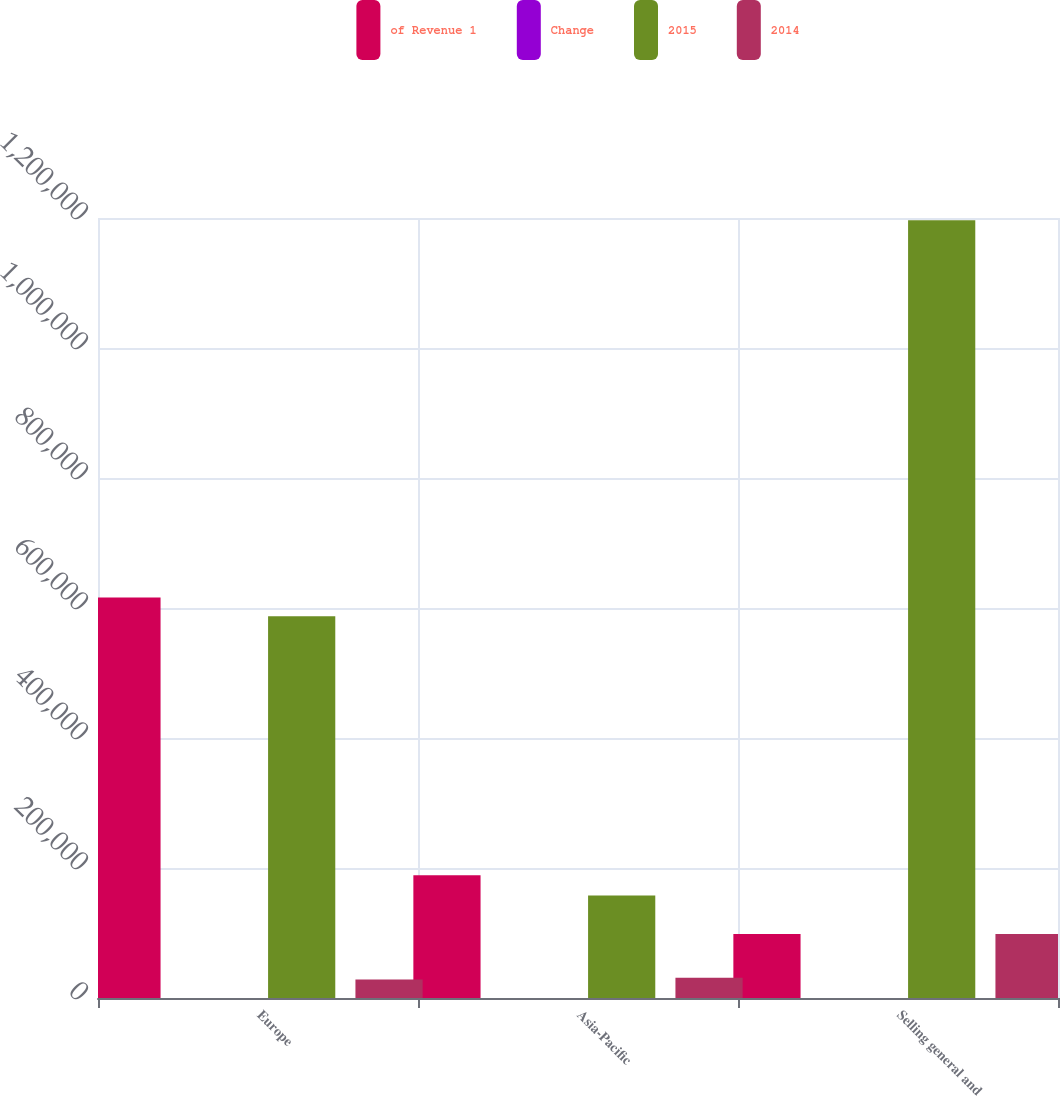Convert chart to OTSL. <chart><loc_0><loc_0><loc_500><loc_500><stacked_bar_chart><ecel><fcel>Europe<fcel>Asia-Pacific<fcel>Selling general and<nl><fcel>of Revenue 1<fcel>615966<fcel>188862<fcel>98502<nl><fcel>Change<fcel>22.2<fcel>6.8<fcel>46.7<nl><fcel>2015<fcel>587463<fcel>157781<fcel>1.19651e+06<nl><fcel>2014<fcel>28503<fcel>31081<fcel>98502<nl></chart> 